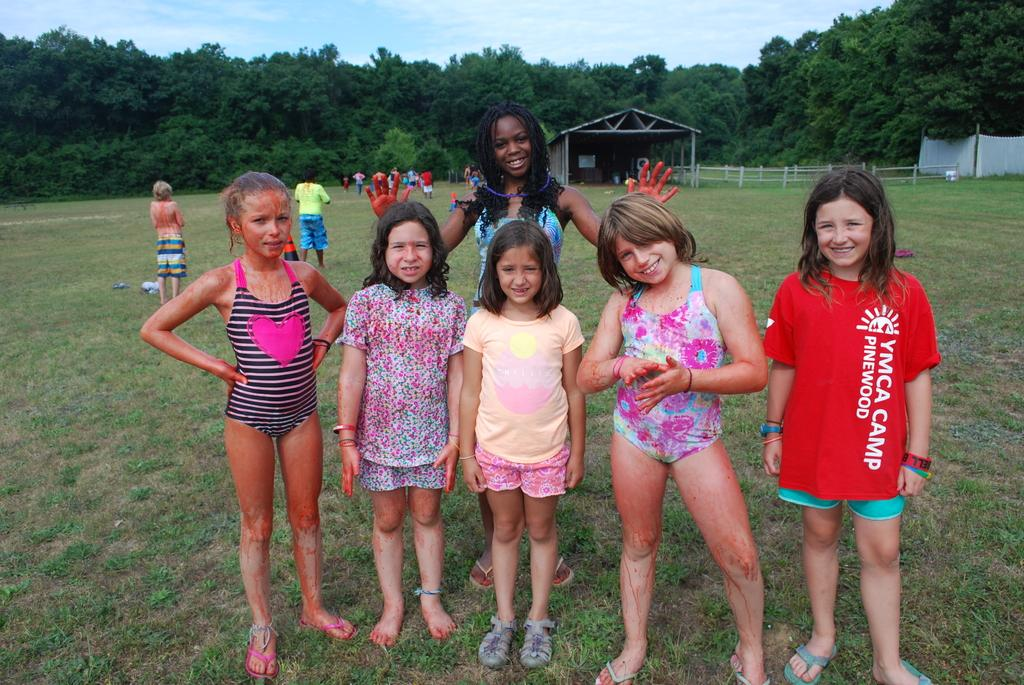What type of vegetation is present in the image? There is grass in the image. Who or what can be seen in the image? There are people in the image. What type of structure is visible in the image? There is a shed in the image. What type of barrier is present in the image? There is fencing in the image. What can be seen in the distance in the image? There are trees in the background of the image. What is visible above the scene in the image? There is a sky visible in the image. What type of food is being prepared in the cannon in the image? There is no cannon or food preparation visible in the image. What type of hole can be seen in the image? There is no hole present in the image. 